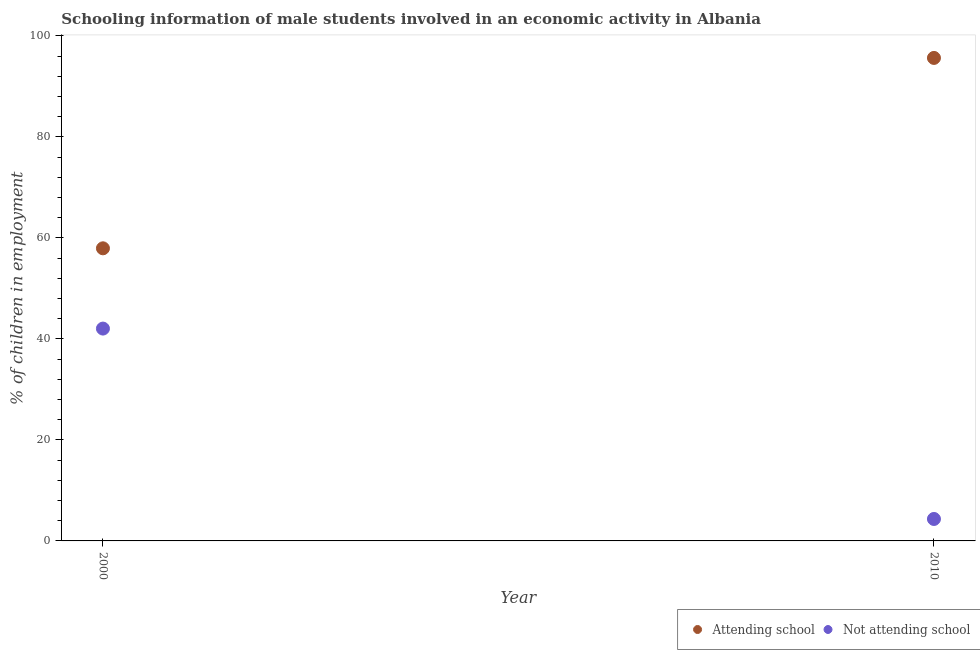How many different coloured dotlines are there?
Your response must be concise. 2. Is the number of dotlines equal to the number of legend labels?
Your response must be concise. Yes. What is the percentage of employed males who are not attending school in 2010?
Your answer should be very brief. 4.35. Across all years, what is the maximum percentage of employed males who are not attending school?
Give a very brief answer. 42.05. Across all years, what is the minimum percentage of employed males who are not attending school?
Offer a very short reply. 4.35. In which year was the percentage of employed males who are not attending school minimum?
Give a very brief answer. 2010. What is the total percentage of employed males who are attending school in the graph?
Your answer should be compact. 153.6. What is the difference between the percentage of employed males who are not attending school in 2000 and that in 2010?
Keep it short and to the point. 37.7. What is the difference between the percentage of employed males who are attending school in 2010 and the percentage of employed males who are not attending school in 2000?
Make the answer very short. 53.6. What is the average percentage of employed males who are attending school per year?
Your answer should be compact. 76.8. In the year 2000, what is the difference between the percentage of employed males who are not attending school and percentage of employed males who are attending school?
Provide a short and direct response. -15.9. In how many years, is the percentage of employed males who are attending school greater than 60 %?
Provide a short and direct response. 1. What is the ratio of the percentage of employed males who are not attending school in 2000 to that in 2010?
Ensure brevity in your answer.  9.67. In how many years, is the percentage of employed males who are attending school greater than the average percentage of employed males who are attending school taken over all years?
Provide a short and direct response. 1. Does the percentage of employed males who are attending school monotonically increase over the years?
Your answer should be compact. Yes. Is the percentage of employed males who are not attending school strictly less than the percentage of employed males who are attending school over the years?
Make the answer very short. Yes. How many years are there in the graph?
Your answer should be very brief. 2. Does the graph contain any zero values?
Keep it short and to the point. No. How many legend labels are there?
Your answer should be very brief. 2. What is the title of the graph?
Your answer should be compact. Schooling information of male students involved in an economic activity in Albania. Does "Crop" appear as one of the legend labels in the graph?
Offer a very short reply. No. What is the label or title of the Y-axis?
Offer a very short reply. % of children in employment. What is the % of children in employment in Attending school in 2000?
Offer a terse response. 57.95. What is the % of children in employment of Not attending school in 2000?
Provide a short and direct response. 42.05. What is the % of children in employment in Attending school in 2010?
Your answer should be very brief. 95.65. What is the % of children in employment of Not attending school in 2010?
Your answer should be very brief. 4.35. Across all years, what is the maximum % of children in employment in Attending school?
Your answer should be very brief. 95.65. Across all years, what is the maximum % of children in employment of Not attending school?
Offer a terse response. 42.05. Across all years, what is the minimum % of children in employment in Attending school?
Give a very brief answer. 57.95. Across all years, what is the minimum % of children in employment of Not attending school?
Make the answer very short. 4.35. What is the total % of children in employment of Attending school in the graph?
Make the answer very short. 153.6. What is the total % of children in employment of Not attending school in the graph?
Your answer should be very brief. 46.4. What is the difference between the % of children in employment of Attending school in 2000 and that in 2010?
Offer a terse response. -37.7. What is the difference between the % of children in employment in Not attending school in 2000 and that in 2010?
Give a very brief answer. 37.7. What is the difference between the % of children in employment of Attending school in 2000 and the % of children in employment of Not attending school in 2010?
Ensure brevity in your answer.  53.6. What is the average % of children in employment of Attending school per year?
Your answer should be very brief. 76.8. What is the average % of children in employment in Not attending school per year?
Your answer should be compact. 23.2. In the year 2000, what is the difference between the % of children in employment of Attending school and % of children in employment of Not attending school?
Ensure brevity in your answer.  15.9. In the year 2010, what is the difference between the % of children in employment in Attending school and % of children in employment in Not attending school?
Keep it short and to the point. 91.31. What is the ratio of the % of children in employment of Attending school in 2000 to that in 2010?
Ensure brevity in your answer.  0.61. What is the ratio of the % of children in employment in Not attending school in 2000 to that in 2010?
Ensure brevity in your answer.  9.67. What is the difference between the highest and the second highest % of children in employment in Attending school?
Give a very brief answer. 37.7. What is the difference between the highest and the second highest % of children in employment of Not attending school?
Your response must be concise. 37.7. What is the difference between the highest and the lowest % of children in employment of Attending school?
Provide a short and direct response. 37.7. What is the difference between the highest and the lowest % of children in employment in Not attending school?
Offer a very short reply. 37.7. 